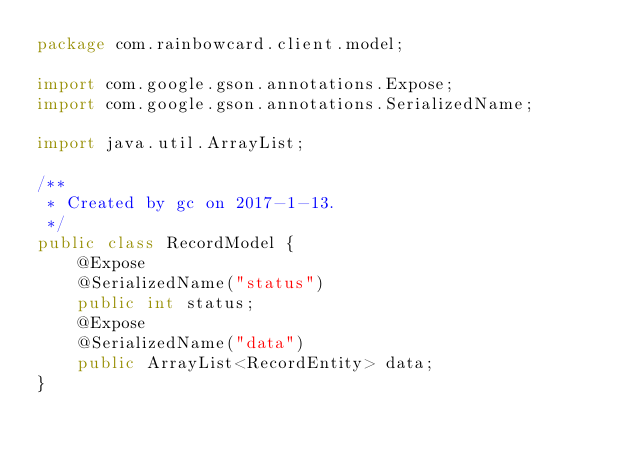<code> <loc_0><loc_0><loc_500><loc_500><_Java_>package com.rainbowcard.client.model;

import com.google.gson.annotations.Expose;
import com.google.gson.annotations.SerializedName;

import java.util.ArrayList;

/**
 * Created by gc on 2017-1-13.
 */
public class RecordModel {
    @Expose
    @SerializedName("status")
    public int status;
    @Expose
    @SerializedName("data")
    public ArrayList<RecordEntity> data;
}
</code> 